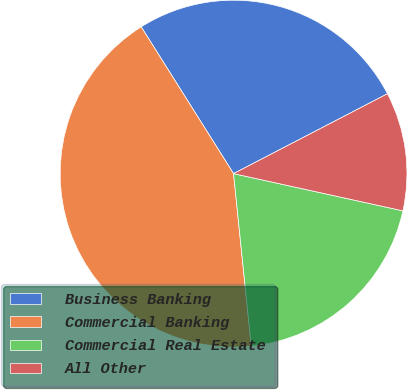Convert chart. <chart><loc_0><loc_0><loc_500><loc_500><pie_chart><fcel>Business Banking<fcel>Commercial Banking<fcel>Commercial Real Estate<fcel>All Other<nl><fcel>26.32%<fcel>42.69%<fcel>19.93%<fcel>11.06%<nl></chart> 